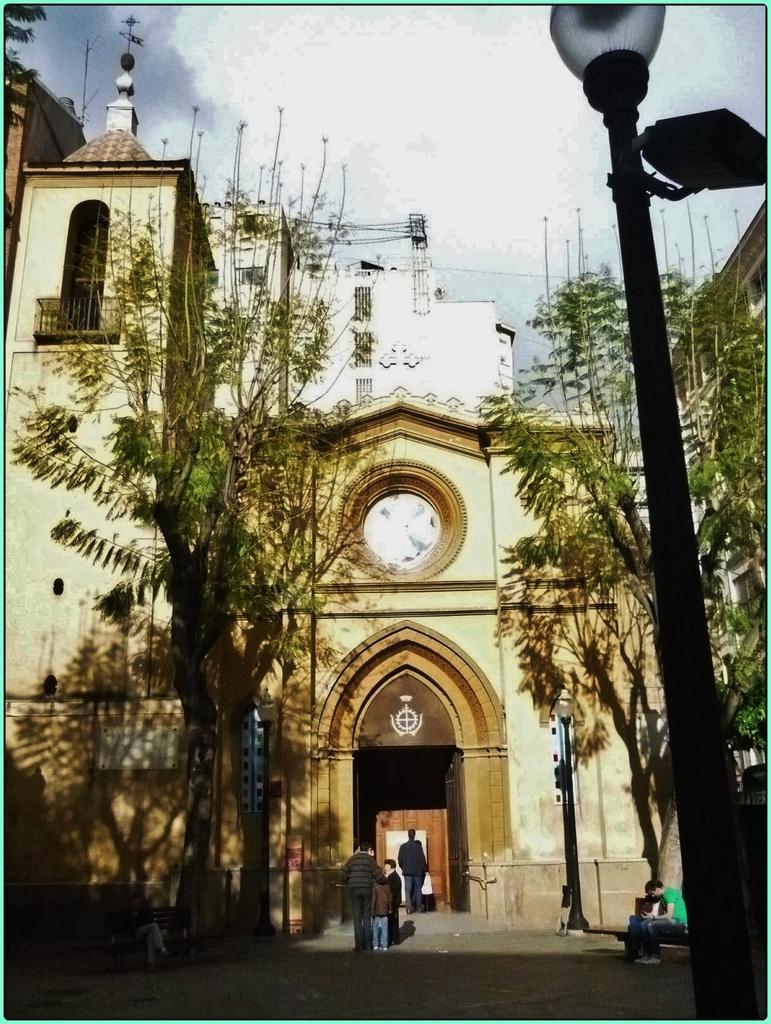Please provide a concise description of this image. In this image, I can see trees, buildings and light poles. At the bottom of the image, there are few people standing and few people sitting on the benches. In the background, there is the sky. 